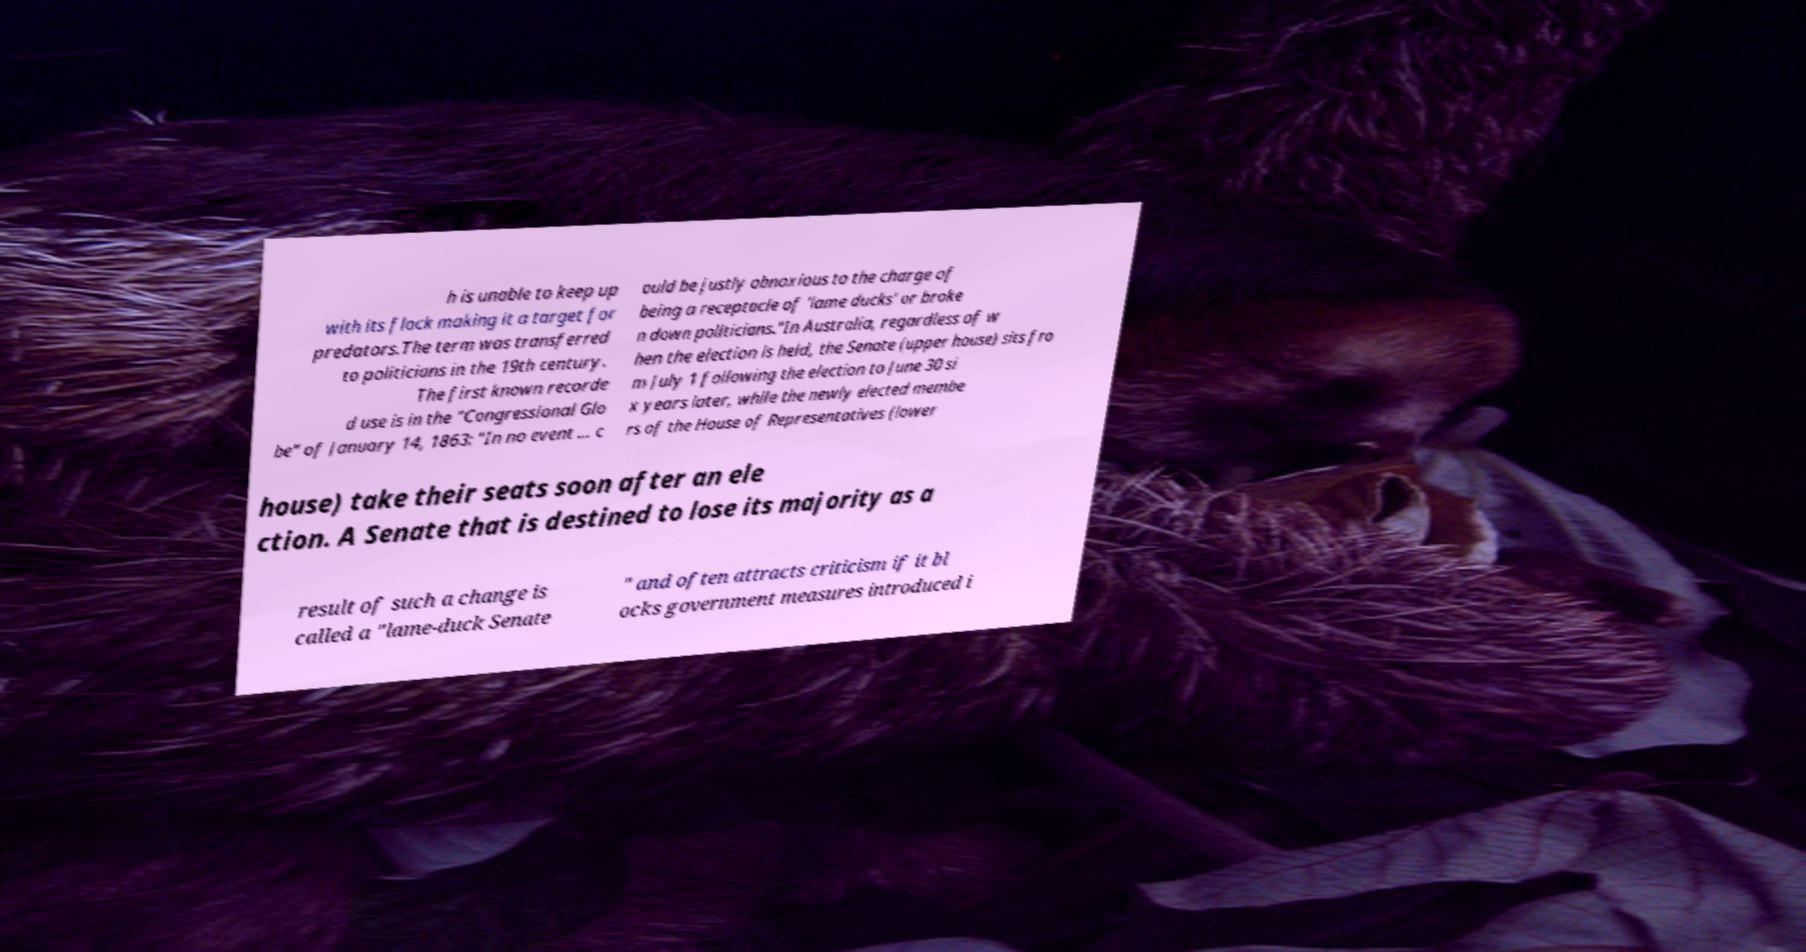Can you read and provide the text displayed in the image?This photo seems to have some interesting text. Can you extract and type it out for me? h is unable to keep up with its flock making it a target for predators.The term was transferred to politicians in the 19th century. The first known recorde d use is in the "Congressional Glo be" of January 14, 1863: "In no event ... c ould be justly obnoxious to the charge of being a receptacle of 'lame ducks' or broke n down politicians."In Australia, regardless of w hen the election is held, the Senate (upper house) sits fro m July 1 following the election to June 30 si x years later, while the newly elected membe rs of the House of Representatives (lower house) take their seats soon after an ele ction. A Senate that is destined to lose its majority as a result of such a change is called a "lame-duck Senate " and often attracts criticism if it bl ocks government measures introduced i 